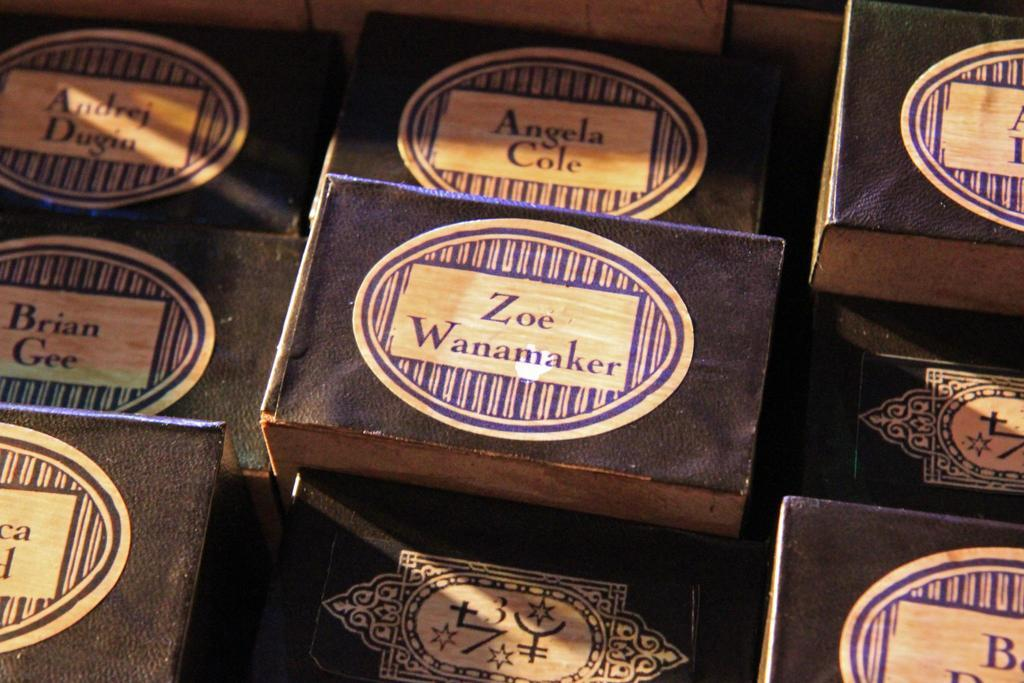What type of objects are present in the image? There are wooden boxes in the image. What can be found on the wooden boxes? There is text and logos on the wooden boxes. What decision is being made by the flag in the image? There is no flag present in the image, so no decision is being made by a flag. 